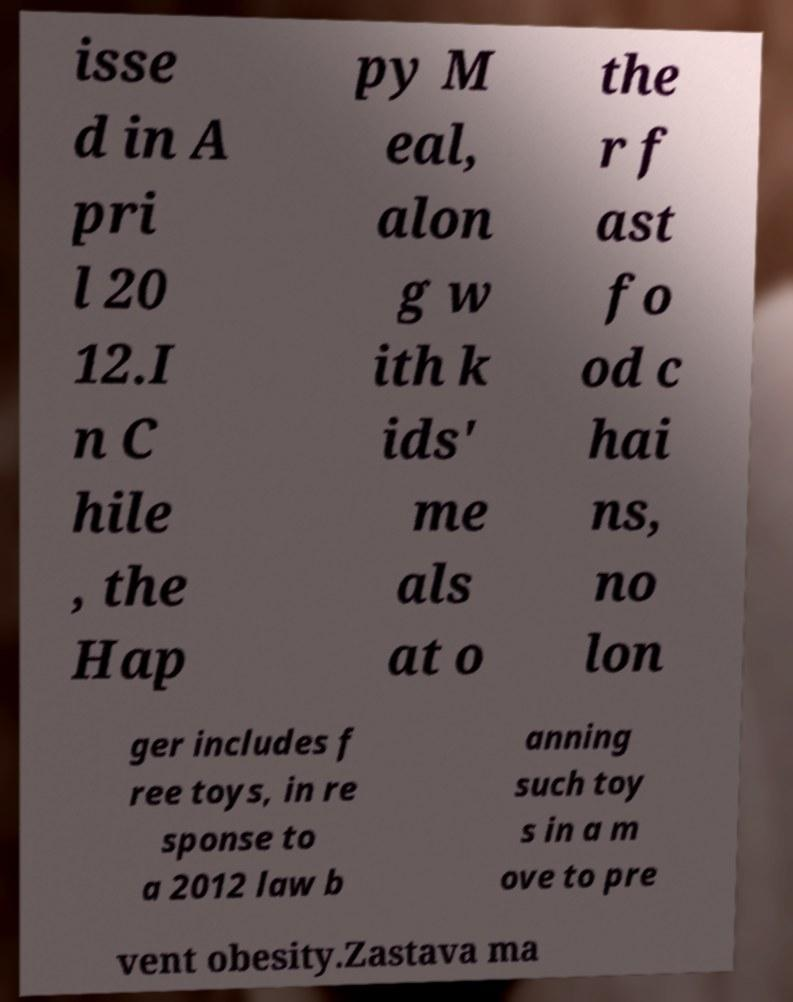What messages or text are displayed in this image? I need them in a readable, typed format. isse d in A pri l 20 12.I n C hile , the Hap py M eal, alon g w ith k ids' me als at o the r f ast fo od c hai ns, no lon ger includes f ree toys, in re sponse to a 2012 law b anning such toy s in a m ove to pre vent obesity.Zastava ma 